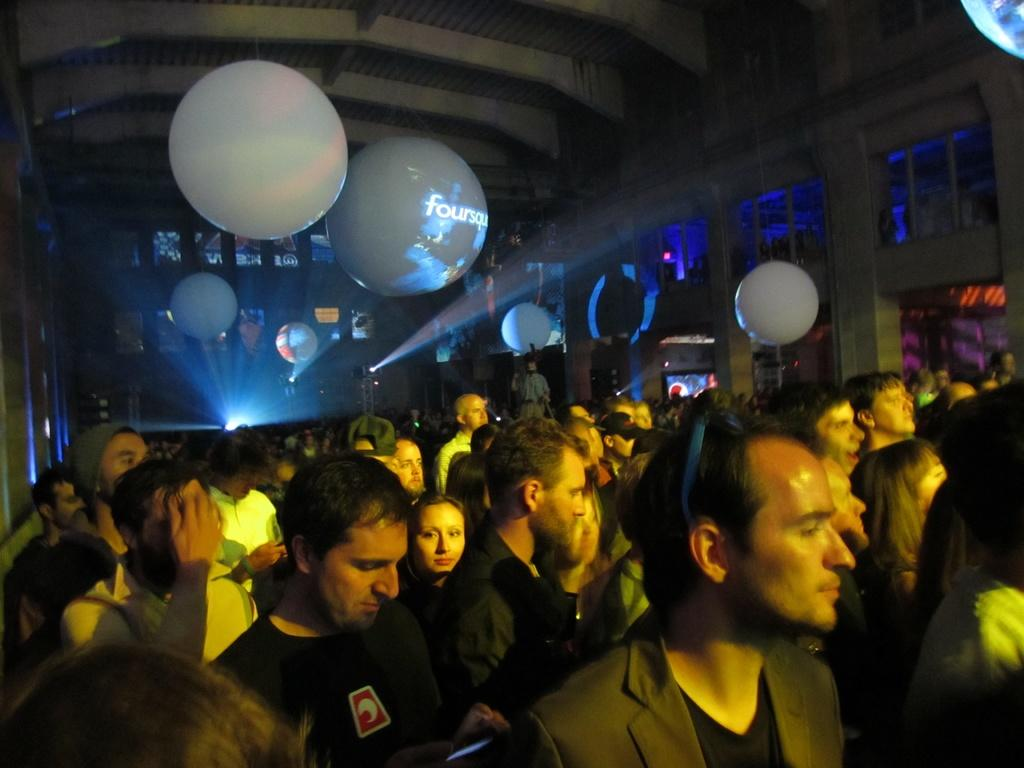What is happening in the image? There are people standing in the image. What can be seen at the top of the image? There are balloons at the top of the image. Is there any source of light in the image? Yes, there is a light in the image. What type of hospital is visible in the image? There is no hospital present in the image. How many borders can be seen in the image? There are no borders visible in the image. 